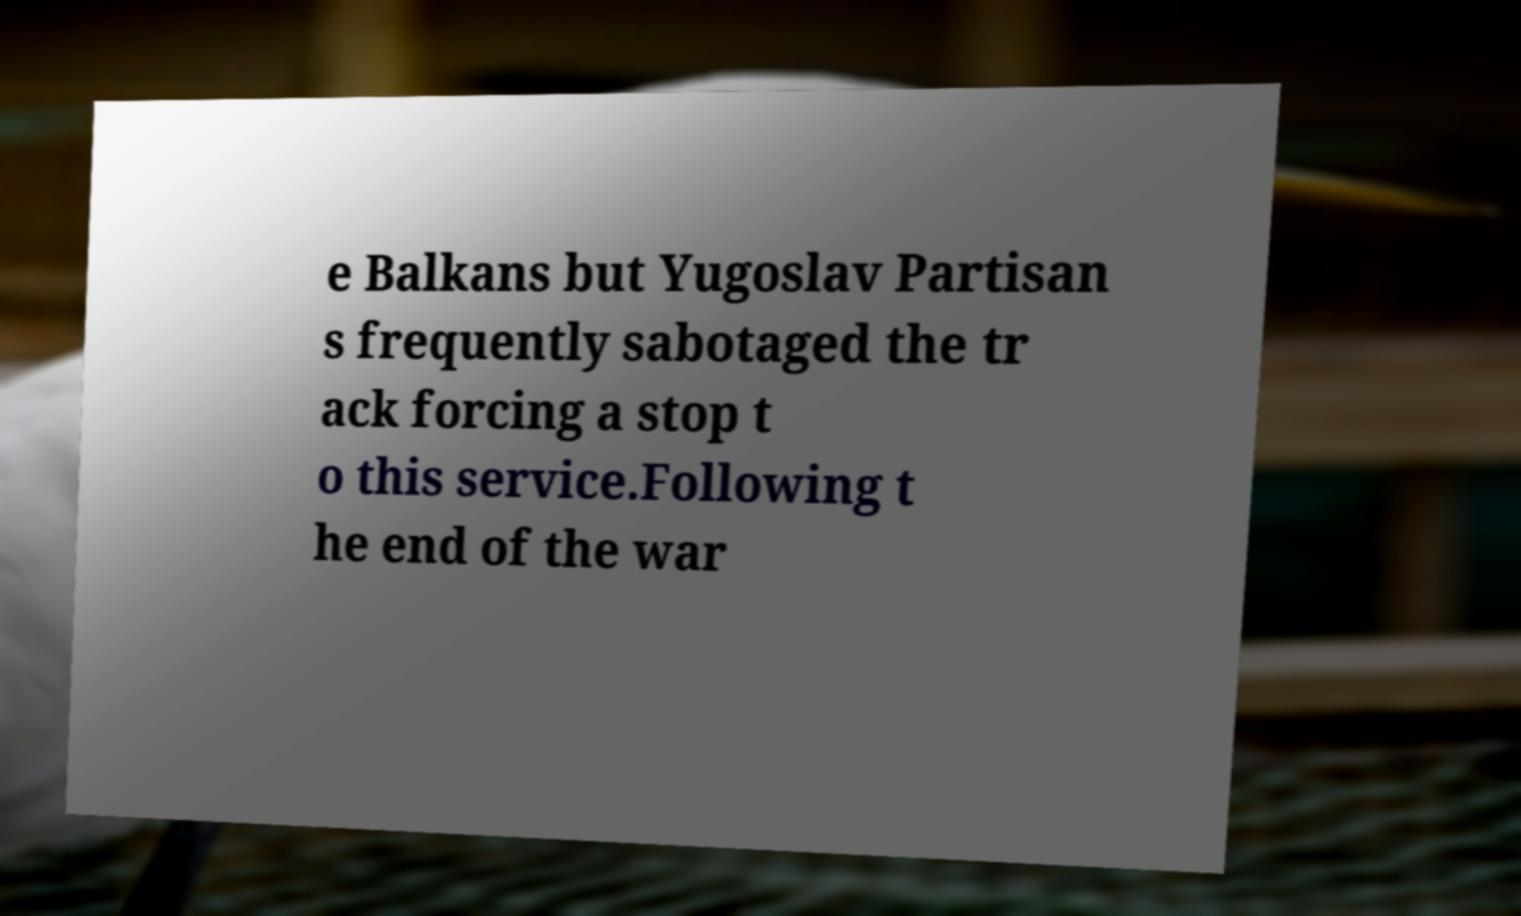Could you extract and type out the text from this image? e Balkans but Yugoslav Partisan s frequently sabotaged the tr ack forcing a stop t o this service.Following t he end of the war 